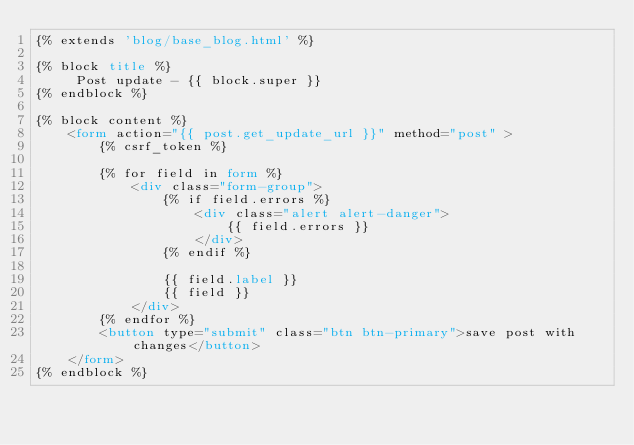<code> <loc_0><loc_0><loc_500><loc_500><_HTML_>{% extends 'blog/base_blog.html' %}

{% block title %}
     Post update - {{ block.super }}
{% endblock %}

{% block content %}
    <form action="{{ post.get_update_url }}" method="post" >
        {% csrf_token %}

        {% for field in form %}
            <div class="form-group">
                {% if field.errors %}
                    <div class="alert alert-danger">
                        {{ field.errors }}
                    </div>
                {% endif %}

                {{ field.label }}
                {{ field }}
            </div>
        {% endfor %}
        <button type="submit" class="btn btn-primary">save post with changes</button>
    </form>
{% endblock %}</code> 